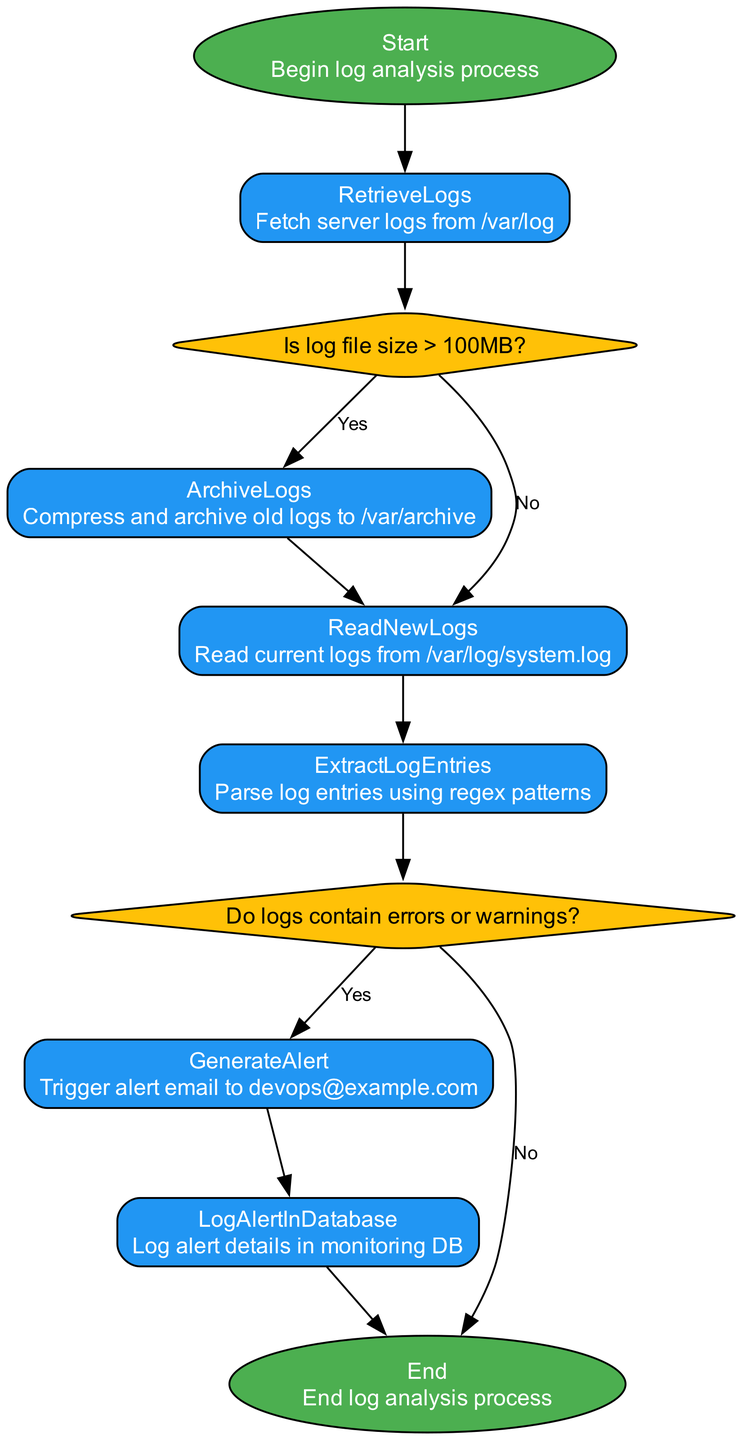What is the first step in the log analysis process? The diagram starts with the node labeled "Start," indicating the beginning of the log analysis process.
Answer: Start How many decision nodes are present in the flowchart? There are two decision nodes: "CheckLogSize" and "CheckErrorPatterns." The count of decision nodes is determined by scanning the diagram for nodes with a diamond shape.
Answer: 2 What action is taken if the log file size is greater than 100MB? If the log file size is greater than 100MB, the flowchart indicates that the process moves to "ArchiveLogs," where old logs will be compressed and archived.
Answer: ArchiveLogs What happens after "ReadNewLogs"? After executing "ReadNewLogs," the next step in the flow is "ExtractLogEntries," indicating the flow direction from reading the logs to extracting log entries.
Answer: ExtractLogEntries What is logged after generating an alert? After generating an alert through the "GenerateAlert" process, the details are logged in "LogAlertInDatabase," which records the alert details in the monitoring database.
Answer: LogAlertInDatabase If no errors or warnings are found in the logs, what is the next step? If no errors or warnings are detected, the flowchart shows that it would proceed to the "End" node, signaling the conclusion of the log analysis process.
Answer: End Which email address is specified for alert generation? The diagram specifies that the alert email is triggered to "devops@example.com" when an alert is generated.
Answer: devops@example.com What processes follow the archival of logs? After the archival of logs in "ArchiveLogs," the next process is "ReadNewLogs," which indicates that the flow returns to reading the current logs post-archiving.
Answer: ReadNewLogs What type of diagram is represented in the provided flowchart? The diagram is a programming flowchart, as indicated by the structured flow of processes, decisions, and the depiction of the analysis sequence for log files and alert generation.
Answer: Programming flowchart 